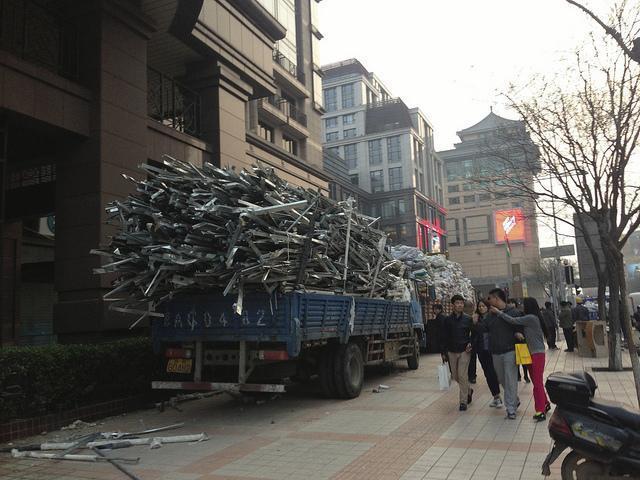How many people can be seen?
Give a very brief answer. 3. How many orange slices are on the top piece of breakfast toast?
Give a very brief answer. 0. 